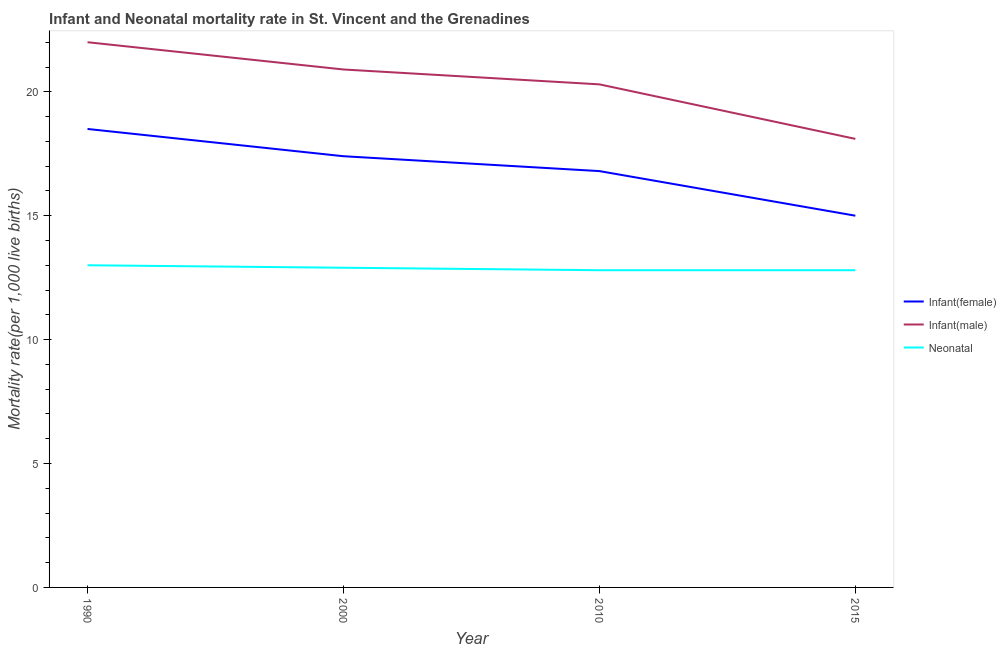How many different coloured lines are there?
Offer a terse response. 3. What is the neonatal mortality rate in 2010?
Offer a very short reply. 12.8. In which year was the infant mortality rate(male) maximum?
Your answer should be compact. 1990. In which year was the neonatal mortality rate minimum?
Make the answer very short. 2010. What is the total neonatal mortality rate in the graph?
Provide a short and direct response. 51.5. What is the difference between the infant mortality rate(female) in 1990 and that in 2010?
Provide a short and direct response. 1.7. What is the difference between the infant mortality rate(female) in 2015 and the infant mortality rate(male) in 2000?
Make the answer very short. -5.9. What is the average neonatal mortality rate per year?
Your answer should be compact. 12.88. What is the ratio of the infant mortality rate(male) in 1990 to that in 2010?
Offer a terse response. 1.08. Is the difference between the infant mortality rate(female) in 1990 and 2000 greater than the difference between the neonatal mortality rate in 1990 and 2000?
Provide a succinct answer. Yes. What is the difference between the highest and the second highest neonatal mortality rate?
Give a very brief answer. 0.1. What is the difference between the highest and the lowest neonatal mortality rate?
Make the answer very short. 0.2. In how many years, is the neonatal mortality rate greater than the average neonatal mortality rate taken over all years?
Give a very brief answer. 2. Is it the case that in every year, the sum of the infant mortality rate(female) and infant mortality rate(male) is greater than the neonatal mortality rate?
Give a very brief answer. Yes. Does the neonatal mortality rate monotonically increase over the years?
Provide a short and direct response. No. Is the neonatal mortality rate strictly greater than the infant mortality rate(male) over the years?
Provide a succinct answer. No. How many lines are there?
Provide a short and direct response. 3. Does the graph contain grids?
Provide a short and direct response. No. How many legend labels are there?
Provide a succinct answer. 3. How are the legend labels stacked?
Ensure brevity in your answer.  Vertical. What is the title of the graph?
Your answer should be compact. Infant and Neonatal mortality rate in St. Vincent and the Grenadines. Does "Unpaid family workers" appear as one of the legend labels in the graph?
Provide a short and direct response. No. What is the label or title of the X-axis?
Ensure brevity in your answer.  Year. What is the label or title of the Y-axis?
Your answer should be very brief. Mortality rate(per 1,0 live births). What is the Mortality rate(per 1,000 live births) in Infant(female) in 1990?
Provide a succinct answer. 18.5. What is the Mortality rate(per 1,000 live births) in Infant(male) in 1990?
Offer a terse response. 22. What is the Mortality rate(per 1,000 live births) in Neonatal  in 1990?
Your response must be concise. 13. What is the Mortality rate(per 1,000 live births) of Infant(female) in 2000?
Ensure brevity in your answer.  17.4. What is the Mortality rate(per 1,000 live births) of Infant(male) in 2000?
Provide a short and direct response. 20.9. What is the Mortality rate(per 1,000 live births) in Neonatal  in 2000?
Keep it short and to the point. 12.9. What is the Mortality rate(per 1,000 live births) in Infant(male) in 2010?
Provide a succinct answer. 20.3. What is the Mortality rate(per 1,000 live births) in Neonatal  in 2010?
Give a very brief answer. 12.8. What is the Mortality rate(per 1,000 live births) in Infant(female) in 2015?
Offer a very short reply. 15. What is the Mortality rate(per 1,000 live births) in Infant(male) in 2015?
Your response must be concise. 18.1. What is the Mortality rate(per 1,000 live births) in Neonatal  in 2015?
Ensure brevity in your answer.  12.8. Across all years, what is the maximum Mortality rate(per 1,000 live births) in Infant(female)?
Make the answer very short. 18.5. Across all years, what is the minimum Mortality rate(per 1,000 live births) of Infant(female)?
Make the answer very short. 15. Across all years, what is the minimum Mortality rate(per 1,000 live births) of Infant(male)?
Provide a succinct answer. 18.1. Across all years, what is the minimum Mortality rate(per 1,000 live births) in Neonatal ?
Ensure brevity in your answer.  12.8. What is the total Mortality rate(per 1,000 live births) in Infant(female) in the graph?
Give a very brief answer. 67.7. What is the total Mortality rate(per 1,000 live births) of Infant(male) in the graph?
Make the answer very short. 81.3. What is the total Mortality rate(per 1,000 live births) in Neonatal  in the graph?
Ensure brevity in your answer.  51.5. What is the difference between the Mortality rate(per 1,000 live births) of Infant(male) in 1990 and that in 2010?
Make the answer very short. 1.7. What is the difference between the Mortality rate(per 1,000 live births) in Neonatal  in 1990 and that in 2010?
Make the answer very short. 0.2. What is the difference between the Mortality rate(per 1,000 live births) in Infant(female) in 1990 and that in 2015?
Your response must be concise. 3.5. What is the difference between the Mortality rate(per 1,000 live births) in Infant(male) in 1990 and that in 2015?
Your answer should be very brief. 3.9. What is the difference between the Mortality rate(per 1,000 live births) of Neonatal  in 1990 and that in 2015?
Offer a terse response. 0.2. What is the difference between the Mortality rate(per 1,000 live births) in Infant(female) in 2000 and that in 2010?
Your answer should be very brief. 0.6. What is the difference between the Mortality rate(per 1,000 live births) in Infant(male) in 2000 and that in 2010?
Ensure brevity in your answer.  0.6. What is the difference between the Mortality rate(per 1,000 live births) of Neonatal  in 2000 and that in 2010?
Ensure brevity in your answer.  0.1. What is the difference between the Mortality rate(per 1,000 live births) of Infant(female) in 2000 and that in 2015?
Your answer should be compact. 2.4. What is the difference between the Mortality rate(per 1,000 live births) of Neonatal  in 2000 and that in 2015?
Provide a succinct answer. 0.1. What is the difference between the Mortality rate(per 1,000 live births) in Infant(male) in 2010 and that in 2015?
Give a very brief answer. 2.2. What is the difference between the Mortality rate(per 1,000 live births) of Infant(female) in 1990 and the Mortality rate(per 1,000 live births) of Neonatal  in 2000?
Offer a very short reply. 5.6. What is the difference between the Mortality rate(per 1,000 live births) in Infant(male) in 1990 and the Mortality rate(per 1,000 live births) in Neonatal  in 2000?
Ensure brevity in your answer.  9.1. What is the difference between the Mortality rate(per 1,000 live births) of Infant(female) in 1990 and the Mortality rate(per 1,000 live births) of Infant(male) in 2010?
Give a very brief answer. -1.8. What is the difference between the Mortality rate(per 1,000 live births) in Infant(male) in 1990 and the Mortality rate(per 1,000 live births) in Neonatal  in 2010?
Your answer should be very brief. 9.2. What is the difference between the Mortality rate(per 1,000 live births) of Infant(female) in 1990 and the Mortality rate(per 1,000 live births) of Neonatal  in 2015?
Offer a very short reply. 5.7. What is the difference between the Mortality rate(per 1,000 live births) of Infant(male) in 1990 and the Mortality rate(per 1,000 live births) of Neonatal  in 2015?
Offer a terse response. 9.2. What is the difference between the Mortality rate(per 1,000 live births) in Infant(female) in 2000 and the Mortality rate(per 1,000 live births) in Infant(male) in 2010?
Provide a succinct answer. -2.9. What is the difference between the Mortality rate(per 1,000 live births) of Infant(female) in 2000 and the Mortality rate(per 1,000 live births) of Neonatal  in 2010?
Give a very brief answer. 4.6. What is the difference between the Mortality rate(per 1,000 live births) of Infant(male) in 2000 and the Mortality rate(per 1,000 live births) of Neonatal  in 2010?
Provide a short and direct response. 8.1. What is the difference between the Mortality rate(per 1,000 live births) of Infant(female) in 2000 and the Mortality rate(per 1,000 live births) of Infant(male) in 2015?
Your response must be concise. -0.7. What is the difference between the Mortality rate(per 1,000 live births) of Infant(female) in 2000 and the Mortality rate(per 1,000 live births) of Neonatal  in 2015?
Ensure brevity in your answer.  4.6. What is the difference between the Mortality rate(per 1,000 live births) of Infant(male) in 2000 and the Mortality rate(per 1,000 live births) of Neonatal  in 2015?
Your answer should be very brief. 8.1. What is the difference between the Mortality rate(per 1,000 live births) of Infant(female) in 2010 and the Mortality rate(per 1,000 live births) of Infant(male) in 2015?
Keep it short and to the point. -1.3. What is the average Mortality rate(per 1,000 live births) of Infant(female) per year?
Give a very brief answer. 16.93. What is the average Mortality rate(per 1,000 live births) in Infant(male) per year?
Your response must be concise. 20.32. What is the average Mortality rate(per 1,000 live births) in Neonatal  per year?
Give a very brief answer. 12.88. In the year 2000, what is the difference between the Mortality rate(per 1,000 live births) in Infant(female) and Mortality rate(per 1,000 live births) in Infant(male)?
Make the answer very short. -3.5. In the year 2010, what is the difference between the Mortality rate(per 1,000 live births) of Infant(female) and Mortality rate(per 1,000 live births) of Infant(male)?
Offer a terse response. -3.5. In the year 2010, what is the difference between the Mortality rate(per 1,000 live births) of Infant(female) and Mortality rate(per 1,000 live births) of Neonatal ?
Your answer should be very brief. 4. In the year 2015, what is the difference between the Mortality rate(per 1,000 live births) in Infant(male) and Mortality rate(per 1,000 live births) in Neonatal ?
Your answer should be compact. 5.3. What is the ratio of the Mortality rate(per 1,000 live births) in Infant(female) in 1990 to that in 2000?
Give a very brief answer. 1.06. What is the ratio of the Mortality rate(per 1,000 live births) in Infant(male) in 1990 to that in 2000?
Your response must be concise. 1.05. What is the ratio of the Mortality rate(per 1,000 live births) in Neonatal  in 1990 to that in 2000?
Offer a terse response. 1.01. What is the ratio of the Mortality rate(per 1,000 live births) in Infant(female) in 1990 to that in 2010?
Keep it short and to the point. 1.1. What is the ratio of the Mortality rate(per 1,000 live births) in Infant(male) in 1990 to that in 2010?
Make the answer very short. 1.08. What is the ratio of the Mortality rate(per 1,000 live births) of Neonatal  in 1990 to that in 2010?
Give a very brief answer. 1.02. What is the ratio of the Mortality rate(per 1,000 live births) in Infant(female) in 1990 to that in 2015?
Provide a succinct answer. 1.23. What is the ratio of the Mortality rate(per 1,000 live births) of Infant(male) in 1990 to that in 2015?
Offer a very short reply. 1.22. What is the ratio of the Mortality rate(per 1,000 live births) in Neonatal  in 1990 to that in 2015?
Give a very brief answer. 1.02. What is the ratio of the Mortality rate(per 1,000 live births) in Infant(female) in 2000 to that in 2010?
Your answer should be very brief. 1.04. What is the ratio of the Mortality rate(per 1,000 live births) of Infant(male) in 2000 to that in 2010?
Keep it short and to the point. 1.03. What is the ratio of the Mortality rate(per 1,000 live births) of Neonatal  in 2000 to that in 2010?
Your answer should be very brief. 1.01. What is the ratio of the Mortality rate(per 1,000 live births) of Infant(female) in 2000 to that in 2015?
Your response must be concise. 1.16. What is the ratio of the Mortality rate(per 1,000 live births) of Infant(male) in 2000 to that in 2015?
Provide a short and direct response. 1.15. What is the ratio of the Mortality rate(per 1,000 live births) of Neonatal  in 2000 to that in 2015?
Make the answer very short. 1.01. What is the ratio of the Mortality rate(per 1,000 live births) of Infant(female) in 2010 to that in 2015?
Make the answer very short. 1.12. What is the ratio of the Mortality rate(per 1,000 live births) of Infant(male) in 2010 to that in 2015?
Make the answer very short. 1.12. What is the ratio of the Mortality rate(per 1,000 live births) in Neonatal  in 2010 to that in 2015?
Provide a short and direct response. 1. What is the difference between the highest and the second highest Mortality rate(per 1,000 live births) in Infant(female)?
Ensure brevity in your answer.  1.1. What is the difference between the highest and the second highest Mortality rate(per 1,000 live births) of Neonatal ?
Keep it short and to the point. 0.1. What is the difference between the highest and the lowest Mortality rate(per 1,000 live births) in Infant(male)?
Ensure brevity in your answer.  3.9. 